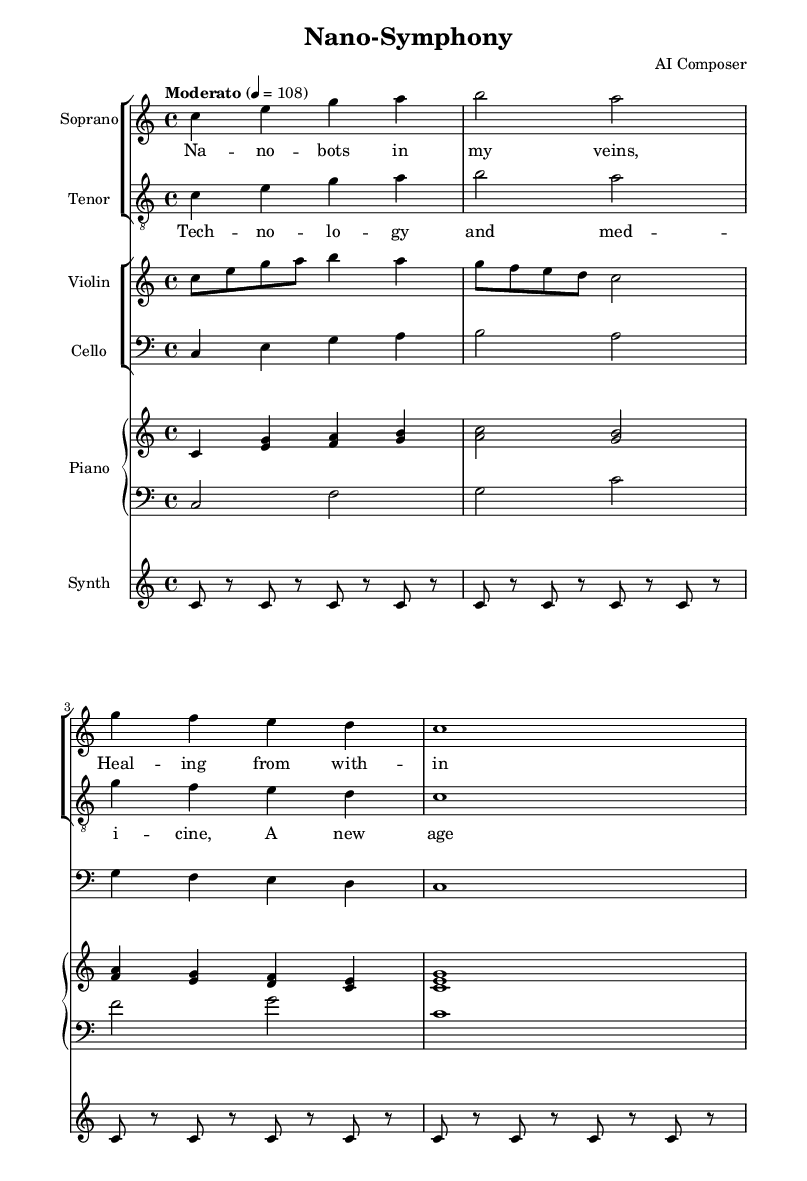What is the key signature of this music? The music is in C major, indicated by the absence of any sharps or flats in the key signature.
Answer: C major What is the time signature? The time signature is 4/4, which is displayed at the beginning of the score, indicating four beats per measure.
Answer: 4/4 What is the tempo marking for the piece? The tempo marking is "Moderato" at a speed of 108 beats per minute, noted at the beginning.
Answer: Moderato How many voices are present in the vocal parts? There are two vocal parts: soprano and tenor. This is evident from the separate staves designated for each voice.
Answer: Two What is the rhythmic pattern of the synth part? The synth part consists of sustained notes with rests, as seen by the repeated "c" notes with alternating rests, creating a drone-like effect.
Answer: Sustained notes with rests What are the primary themes explored through the lyrics? The lyrics reflect themes of healing and the merging of technology and medicine, emphasizing a modern and transformative experience.
Answer: Healing and technology In what format is the music displayed? The music is formatted as a score, which displays different instrumental and vocal parts on separate staves, typical for operatic compositions.
Answer: Score 